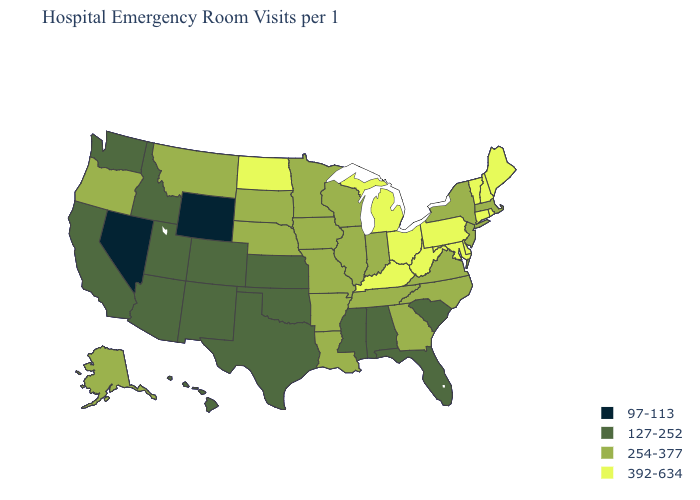Name the states that have a value in the range 392-634?
Short answer required. Connecticut, Delaware, Kentucky, Maine, Maryland, Michigan, New Hampshire, North Dakota, Ohio, Pennsylvania, Rhode Island, Vermont, West Virginia. Name the states that have a value in the range 254-377?
Short answer required. Alaska, Arkansas, Georgia, Illinois, Indiana, Iowa, Louisiana, Massachusetts, Minnesota, Missouri, Montana, Nebraska, New Jersey, New York, North Carolina, Oregon, South Dakota, Tennessee, Virginia, Wisconsin. Which states have the lowest value in the USA?
Give a very brief answer. Nevada, Wyoming. What is the lowest value in states that border Idaho?
Keep it brief. 97-113. What is the value of New York?
Be succinct. 254-377. Does Missouri have the highest value in the MidWest?
Answer briefly. No. Name the states that have a value in the range 127-252?
Keep it brief. Alabama, Arizona, California, Colorado, Florida, Hawaii, Idaho, Kansas, Mississippi, New Mexico, Oklahoma, South Carolina, Texas, Utah, Washington. What is the value of Delaware?
Keep it brief. 392-634. Does the map have missing data?
Answer briefly. No. What is the value of West Virginia?
Concise answer only. 392-634. Does Wisconsin have the lowest value in the USA?
Concise answer only. No. What is the lowest value in the MidWest?
Keep it brief. 127-252. What is the lowest value in the Northeast?
Keep it brief. 254-377. Name the states that have a value in the range 127-252?
Write a very short answer. Alabama, Arizona, California, Colorado, Florida, Hawaii, Idaho, Kansas, Mississippi, New Mexico, Oklahoma, South Carolina, Texas, Utah, Washington. Which states hav the highest value in the MidWest?
Short answer required. Michigan, North Dakota, Ohio. 